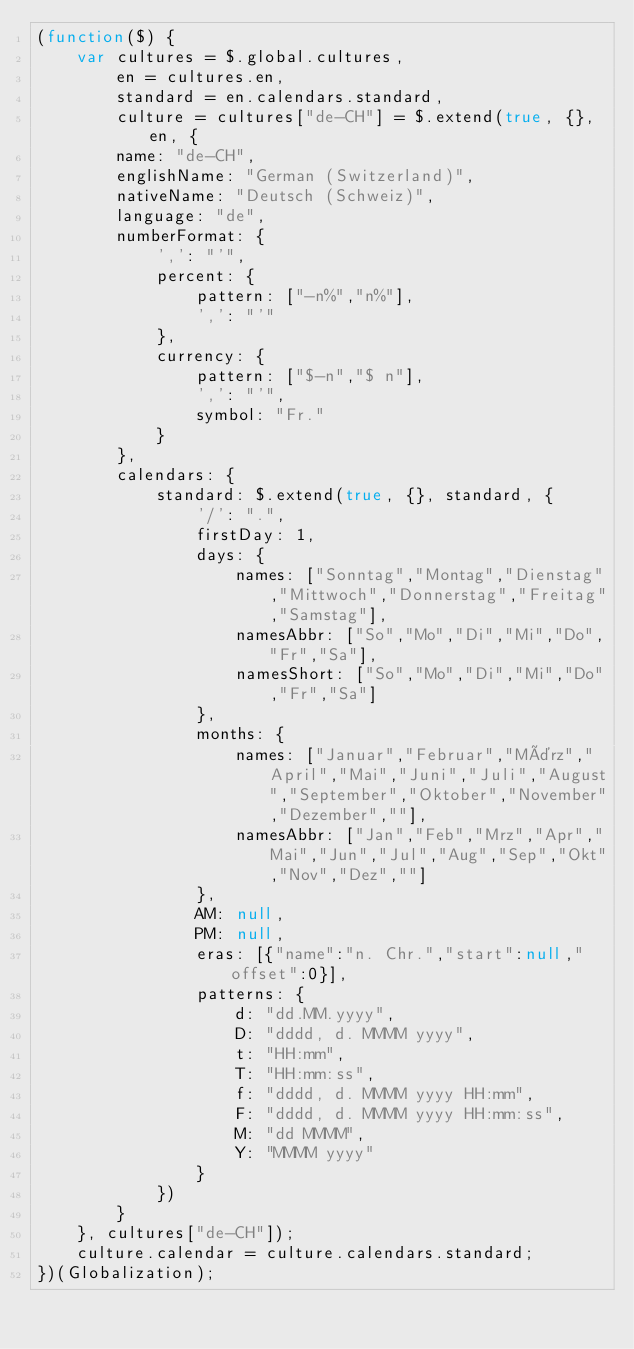Convert code to text. <code><loc_0><loc_0><loc_500><loc_500><_JavaScript_>(function($) {
    var cultures = $.global.cultures,
        en = cultures.en,
        standard = en.calendars.standard,
        culture = cultures["de-CH"] = $.extend(true, {}, en, {
        name: "de-CH",
        englishName: "German (Switzerland)",
        nativeName: "Deutsch (Schweiz)",
        language: "de",
        numberFormat: {
            ',': "'",
            percent: {
                pattern: ["-n%","n%"],
                ',': "'"
            },
            currency: {
                pattern: ["$-n","$ n"],
                ',': "'",
                symbol: "Fr."
            }
        },
        calendars: {
            standard: $.extend(true, {}, standard, {
                '/': ".",
                firstDay: 1,
                days: {
                    names: ["Sonntag","Montag","Dienstag","Mittwoch","Donnerstag","Freitag","Samstag"],
                    namesAbbr: ["So","Mo","Di","Mi","Do","Fr","Sa"],
                    namesShort: ["So","Mo","Di","Mi","Do","Fr","Sa"]
                },
                months: {
                    names: ["Januar","Februar","März","April","Mai","Juni","Juli","August","September","Oktober","November","Dezember",""],
                    namesAbbr: ["Jan","Feb","Mrz","Apr","Mai","Jun","Jul","Aug","Sep","Okt","Nov","Dez",""]
                },
                AM: null,
                PM: null,
                eras: [{"name":"n. Chr.","start":null,"offset":0}],
                patterns: {
                    d: "dd.MM.yyyy",
                    D: "dddd, d. MMMM yyyy",
                    t: "HH:mm",
                    T: "HH:mm:ss",
                    f: "dddd, d. MMMM yyyy HH:mm",
                    F: "dddd, d. MMMM yyyy HH:mm:ss",
                    M: "dd MMMM",
                    Y: "MMMM yyyy"
                }
            })
        }
    }, cultures["de-CH"]);
    culture.calendar = culture.calendars.standard;
})(Globalization);</code> 